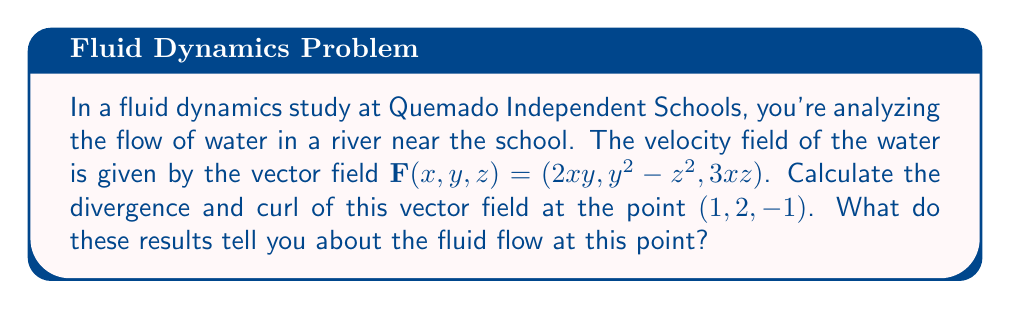Can you solve this math problem? Let's approach this problem step-by-step:

1) First, recall the formulas for divergence and curl:

   Divergence: $\nabla \cdot \mathbf{F} = \frac{\partial F_x}{\partial x} + \frac{\partial F_y}{\partial y} + \frac{\partial F_z}{\partial z}$

   Curl: $\nabla \times \mathbf{F} = \left(\frac{\partial F_z}{\partial y} - \frac{\partial F_y}{\partial z}\right)\mathbf{i} + \left(\frac{\partial F_x}{\partial z} - \frac{\partial F_z}{\partial x}\right)\mathbf{j} + \left(\frac{\partial F_y}{\partial x} - \frac{\partial F_x}{\partial y}\right)\mathbf{k}$

2) For the given vector field $\mathbf{F}(x,y,z) = (2xy, y^2 - z^2, 3xz)$:
   
   $F_x = 2xy$
   $F_y = y^2 - z^2$
   $F_z = 3xz$

3) Let's calculate the divergence:

   $\frac{\partial F_x}{\partial x} = 2y$
   $\frac{\partial F_y}{\partial y} = 2y$
   $\frac{\partial F_z}{\partial z} = 3x$

   $\nabla \cdot \mathbf{F} = 2y + 2y + 3x = 4y + 3x$

   At the point (1, 2, -1): $\nabla \cdot \mathbf{F} = 4(2) + 3(1) = 11$

4) Now, let's calculate the curl:

   $\frac{\partial F_z}{\partial y} - \frac{\partial F_y}{\partial z} = 0 - (-2z) = 2z$
   $\frac{\partial F_x}{\partial z} - \frac{\partial F_z}{\partial x} = 0 - 3z = -3z$
   $\frac{\partial F_y}{\partial x} - \frac{\partial F_x}{\partial y} = 0 - 2x = -2x$

   $\nabla \times \mathbf{F} = (2z)\mathbf{i} + (-3z)\mathbf{j} + (-2x)\mathbf{k}$

   At the point (1, 2, -1): $\nabla \times \mathbf{F} = -2\mathbf{i} + 3\mathbf{j} - 2\mathbf{k}$

5) Interpretation:
   - The positive divergence (11) indicates that the fluid is expanding or spreading out at this point.
   - The non-zero curl indicates that there is rotation in the fluid at this point.
Answer: Divergence: 11
Curl: $-2\mathbf{i} + 3\mathbf{j} - 2\mathbf{k}$

The positive divergence indicates fluid expansion, while the non-zero curl shows rotation at the point (1, 2, -1). 